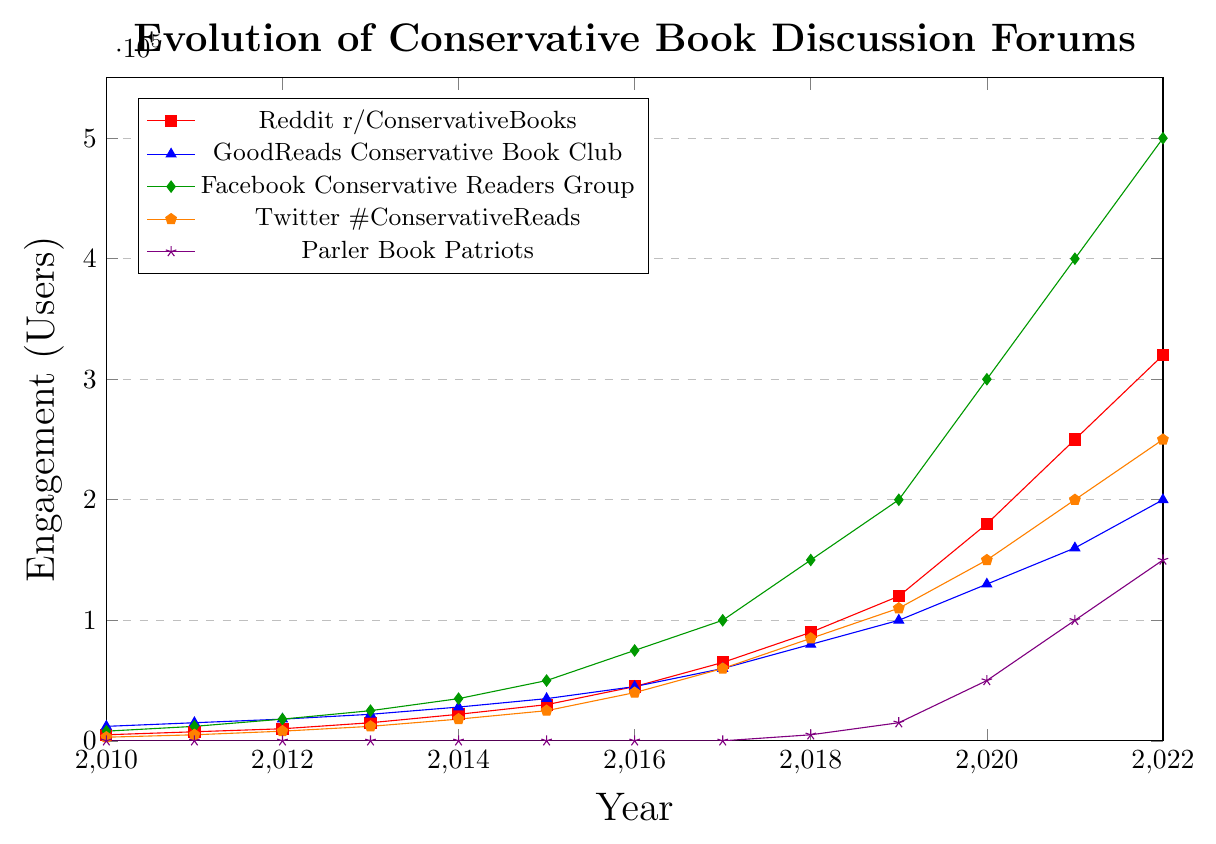What is the total engagement for Reddit r/ConservativeBooks and Twitter \#ConservativeReads in 2022? Add the engagement for Reddit r/ConservativeBooks (320,000) and Twitter \#ConservativeReads (250,000) in 2022.
Answer: 570,000 Which platform saw the highest increase in engagement from 2010 to 2022? Compare the differences in engagement from 2010 to 2022 for all platforms. Reddit increased by 315,000, GoodReads by 188,000, Facebook by 492,000, Twitter by 247,000, and Parler by 150,000.
Answer: Facebook Conservative Readers Group In which year did Parler Book Patriots first record online engagement? Look for the first non-zero value in the Parler Book Patriots line. It occurs in 2018.
Answer: 2018 How does the engagement in 2018 for GoodReads Conservative Book Club compare to Parler Book Patriots? Compare the engagement in 2018 between GoodReads (80,000) and Parler (5,000). GoodReads has higher engagement.
Answer: GoodReads has higher engagement What is the trend in engagement for Facebook Conservative Readers Group from 2010 to 2022? Observe the line representing Facebook: it starts from 8,000 in 2010 and steadily increases to 500,000 in 2022.
Answer: Steadily increasing Which platform had the smallest engagement in 2016? Check the engagement values for all platforms in 2016: Reddit (45,000), GoodReads (45,000), Facebook (75,000), Twitter (40,000), and Parler (0). Parler had the smallest engagement.
Answer: Parler Book Patriots How did Twitter \#ConservativeReads engagement change from 2010 to 2014? Calculate the change in Twitter engagement from 2010 (3,000) to 2014 (18,000). The increase is 15,000.
Answer: Increased by 15,000 In 2020, which two platforms have the closest engagement levels and what are those values? Compare the engagement levels in 2020 for all platforms. GoodReads (130,000) and Twitter (150,000) are the closest. The values are 130,000 and 150,000.
Answer: GoodReads Conservative Book Club (130,000) and Twitter \#ConservativeReads (150,000) Among all the platforms, which one showed engagement only after 2017? Identify the platform that has zero engagement until after 2017. It's Parler Book Patriots.
Answer: Parler Book Patriots 